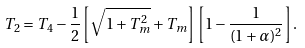Convert formula to latex. <formula><loc_0><loc_0><loc_500><loc_500>T _ { 2 } = T _ { 4 } - \frac { 1 } { 2 } \left [ \sqrt { 1 + T _ { m } ^ { 2 } } + T _ { m } \right ] \left [ 1 - \frac { 1 } { ( 1 + \alpha ) ^ { 2 } } \right ] .</formula> 